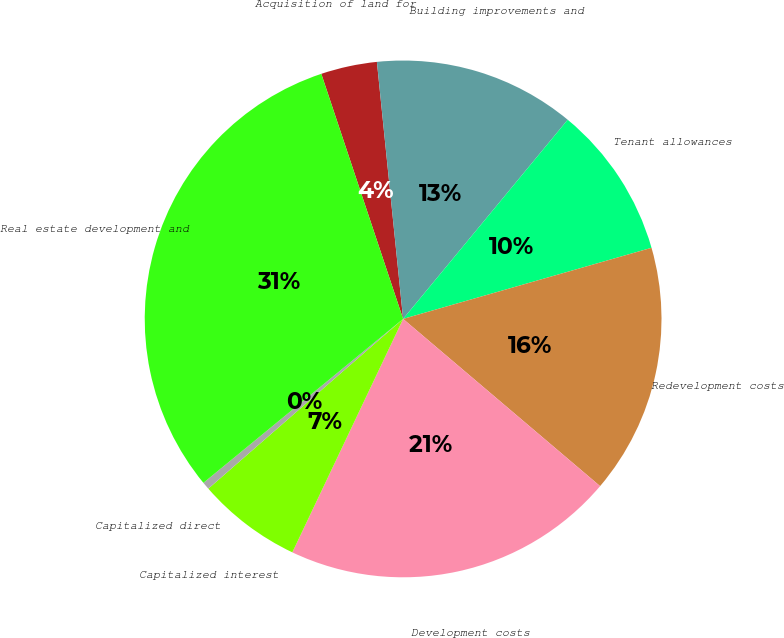Convert chart. <chart><loc_0><loc_0><loc_500><loc_500><pie_chart><fcel>Acquisition of land for<fcel>Building improvements and<fcel>Tenant allowances<fcel>Redevelopment costs<fcel>Development costs<fcel>Capitalized interest<fcel>Capitalized direct<fcel>Real estate development and<nl><fcel>3.51%<fcel>12.61%<fcel>9.57%<fcel>15.64%<fcel>20.85%<fcel>6.54%<fcel>0.47%<fcel>30.81%<nl></chart> 